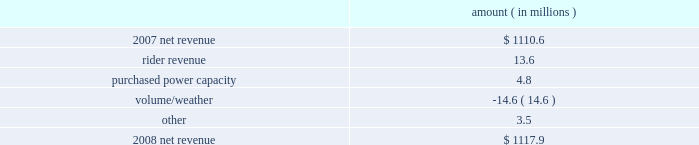Entergy arkansas , inc .
Management's financial discussion and analysis results of operations net income 2008 compared to 2007 net income decreased $ 92.0 million primarily due to higher other operation and maintenance expenses , higher depreciation and amortization expenses , and a higher effective income tax rate , partially offset by higher net revenue .
The higher other operation and maintenance expenses resulted primarily from the write-off of approximately $ 70.8 million of costs as a result of the december 2008 arkansas court of appeals decision in entergy arkansas' base rate case .
The base rate case is discussed in more detail in note 2 to the financial statements .
2007 compared to 2006 net income decreased $ 34.0 million primarily due to higher other operation and maintenance expenses , higher depreciation and amortization expenses , and a higher effective income tax rate .
The decrease was partially offset by higher net revenue .
Net revenue 2008 compared to 2007 net revenue consists of operating revenues net of : 1 ) fuel , fuel-related expenses , and gas purchased for resale , 2 ) purchased power expenses , and 3 ) other regulatory credits .
Following is an analysis of the change in net revenue comparing 2008 to 2007 .
Amount ( in millions ) .
The rider revenue variance is primarily due to an energy efficiency rider which became effective in november 2007 .
The establishment of the rider results in an increase in rider revenue and a corresponding increase in other operation and maintenance expense with no effect on net income .
Also contributing to the variance was an increase in franchise tax rider revenue as a result of higher retail revenues .
The corresponding increase is in taxes other than income taxes , resulting in no effect on net income .
The purchased power capacity variance is primarily due to lower reserve equalization expenses .
The volume/weather variance is primarily due to the effect of less favorable weather on residential and commercial sales during the billed and unbilled sales periods compared to 2007 and a 2.9% ( 2.9 % ) volume decrease in industrial sales , primarily in the wood industry and the small customer class .
Billed electricity usage decreased 333 gwh in all sectors .
See "critical accounting estimates" below and note 1 to the financial statements for further discussion of the accounting for unbilled revenues. .
What percent of the net change in revenue between 2007 and 2008 was due to rider revenue? 
Computations: (13.6 / (1110.6 - 1117.9))
Answer: -1.86301. 